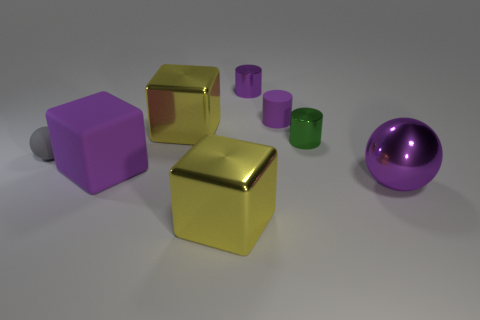Subtract all purple matte blocks. How many blocks are left? 2 Add 1 large purple spheres. How many large purple spheres are left? 2 Add 6 green things. How many green things exist? 7 Add 2 red balls. How many objects exist? 10 Subtract all green cylinders. How many cylinders are left? 2 Subtract 0 cyan blocks. How many objects are left? 8 Subtract all blocks. How many objects are left? 5 Subtract 3 cylinders. How many cylinders are left? 0 Subtract all blue cylinders. Subtract all blue spheres. How many cylinders are left? 3 Subtract all purple cylinders. How many gray spheres are left? 1 